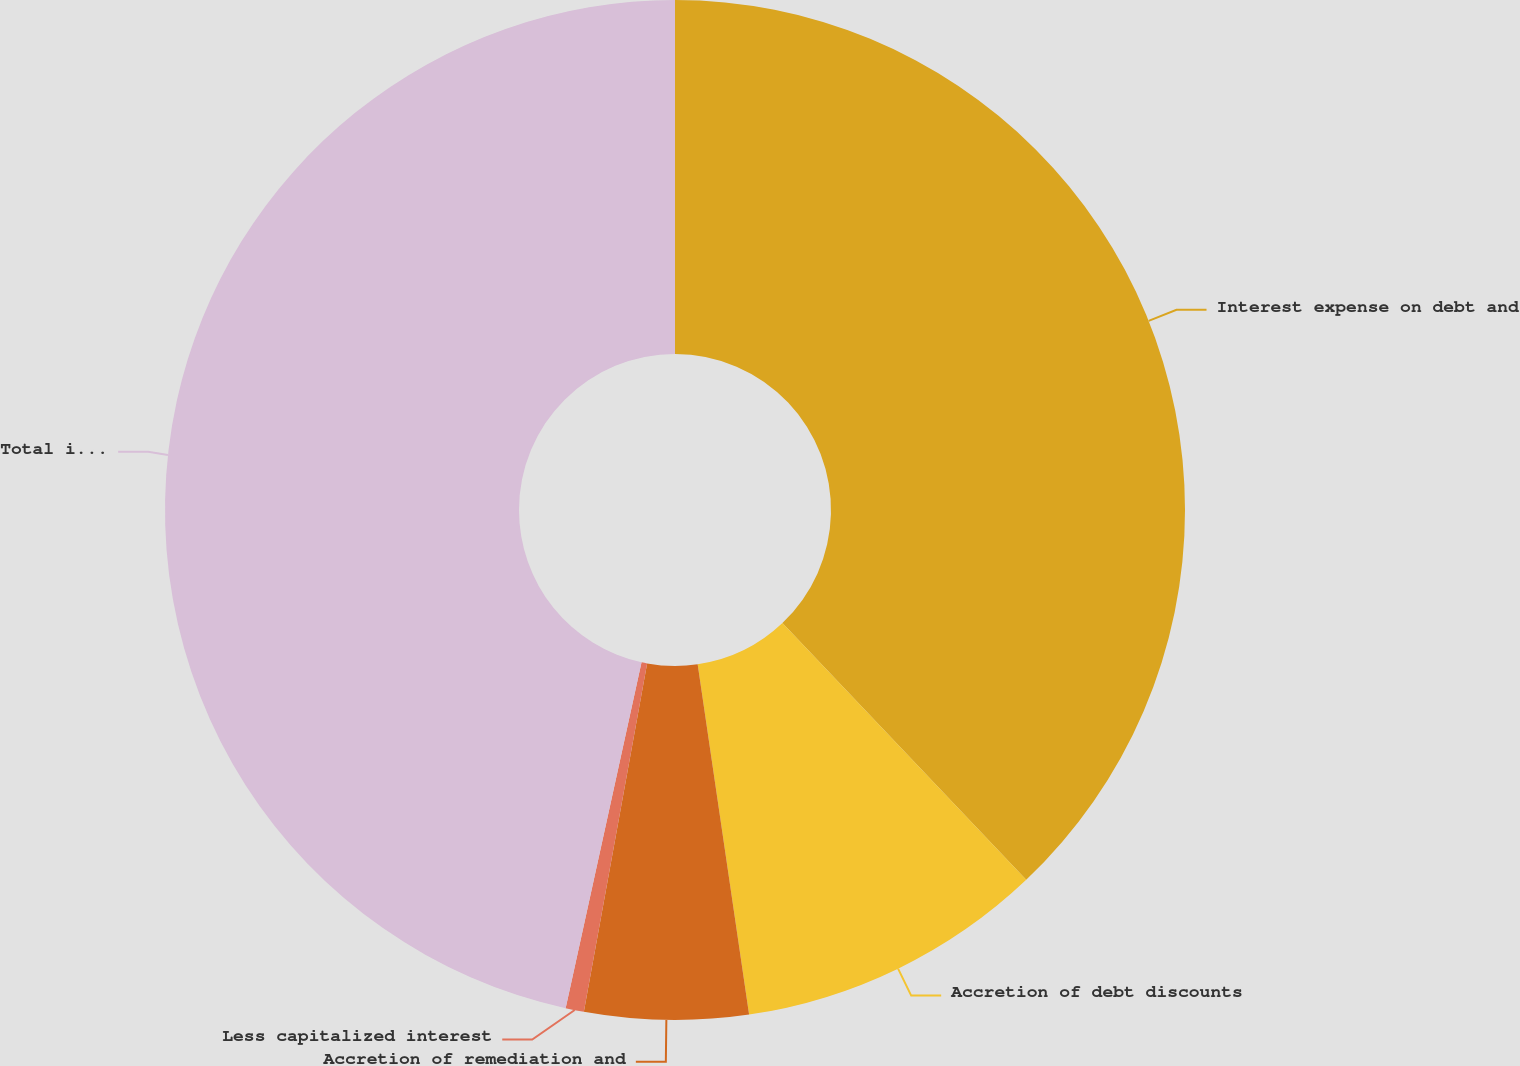Convert chart to OTSL. <chart><loc_0><loc_0><loc_500><loc_500><pie_chart><fcel>Interest expense on debt and<fcel>Accretion of debt discounts<fcel>Accretion of remediation and<fcel>Less capitalized interest<fcel>Total interest expense<nl><fcel>37.91%<fcel>9.77%<fcel>5.18%<fcel>0.58%<fcel>46.56%<nl></chart> 